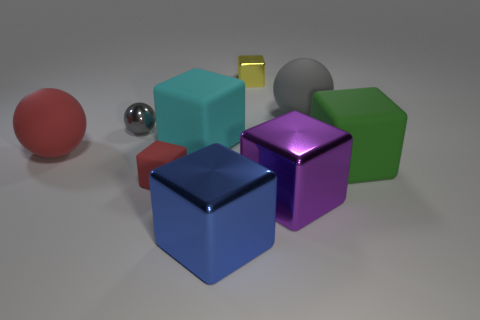Subtract 1 blocks. How many blocks are left? 5 Subtract all tiny matte cubes. How many cubes are left? 5 Subtract all blue blocks. How many blocks are left? 5 Subtract all red blocks. Subtract all blue balls. How many blocks are left? 5 Add 1 brown metal cylinders. How many objects exist? 10 Subtract all blocks. How many objects are left? 3 Subtract 0 brown cubes. How many objects are left? 9 Subtract all gray metallic objects. Subtract all small brown matte spheres. How many objects are left? 8 Add 1 red matte objects. How many red matte objects are left? 3 Add 1 red rubber balls. How many red rubber balls exist? 2 